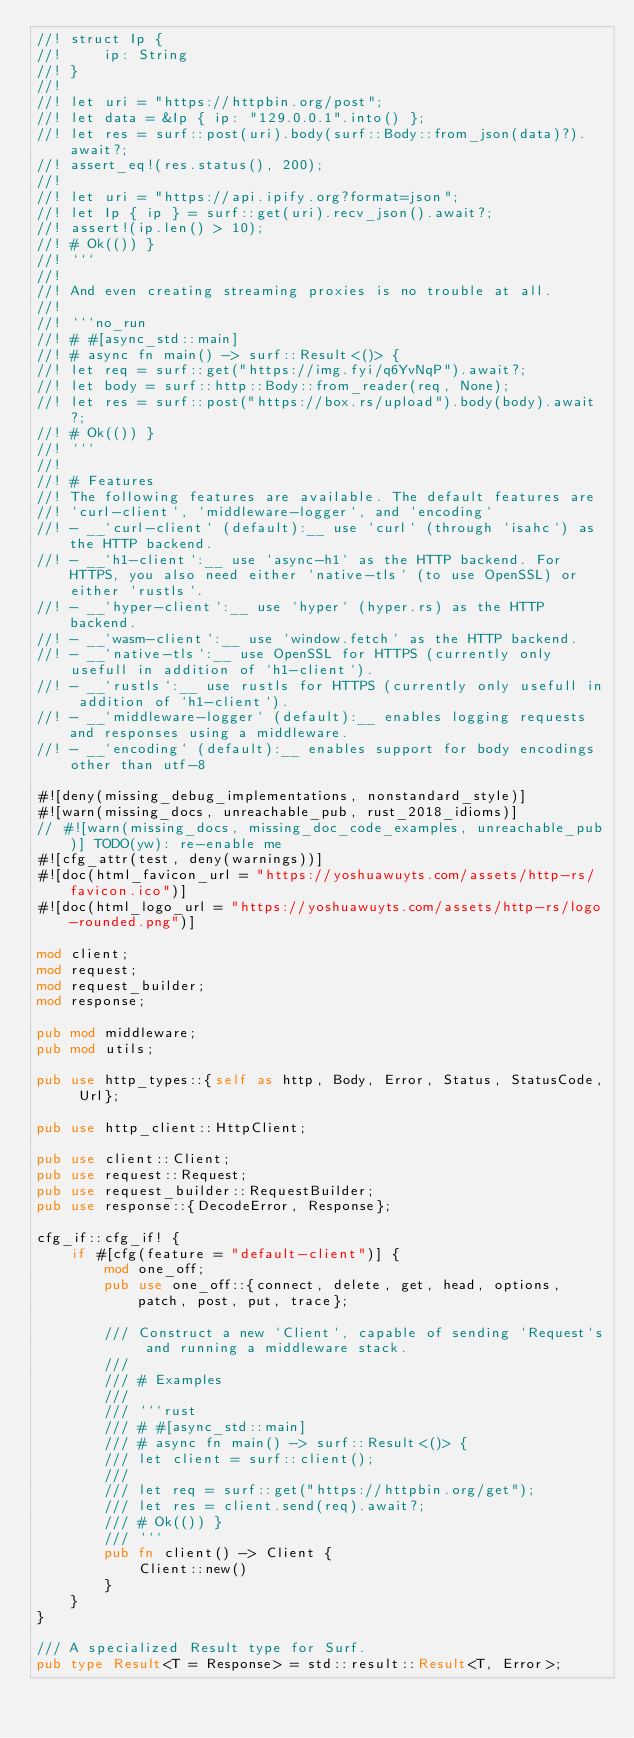Convert code to text. <code><loc_0><loc_0><loc_500><loc_500><_Rust_>//! struct Ip {
//!     ip: String
//! }
//!
//! let uri = "https://httpbin.org/post";
//! let data = &Ip { ip: "129.0.0.1".into() };
//! let res = surf::post(uri).body(surf::Body::from_json(data)?).await?;
//! assert_eq!(res.status(), 200);
//!
//! let uri = "https://api.ipify.org?format=json";
//! let Ip { ip } = surf::get(uri).recv_json().await?;
//! assert!(ip.len() > 10);
//! # Ok(()) }
//! ```
//!
//! And even creating streaming proxies is no trouble at all.
//!
//! ```no_run
//! # #[async_std::main]
//! # async fn main() -> surf::Result<()> {
//! let req = surf::get("https://img.fyi/q6YvNqP").await?;
//! let body = surf::http::Body::from_reader(req, None);
//! let res = surf::post("https://box.rs/upload").body(body).await?;
//! # Ok(()) }
//! ```
//!
//! # Features
//! The following features are available. The default features are
//! `curl-client`, `middleware-logger`, and `encoding`
//! - __`curl-client` (default):__ use `curl` (through `isahc`) as the HTTP backend.
//! - __`h1-client`:__ use `async-h1` as the HTTP backend. For HTTPS, you also need either `native-tls` (to use OpenSSL) or either `rustls`.
//! - __`hyper-client`:__ use `hyper` (hyper.rs) as the HTTP backend.
//! - __`wasm-client`:__ use `window.fetch` as the HTTP backend.
//! - __`native-tls`:__ use OpenSSL for HTTPS (currently only usefull in addition of `h1-client`).
//! - __`rustls`:__ use rustls for HTTPS (currently only usefull in addition of `h1-client`).
//! - __`middleware-logger` (default):__ enables logging requests and responses using a middleware.
//! - __`encoding` (default):__ enables support for body encodings other than utf-8

#![deny(missing_debug_implementations, nonstandard_style)]
#![warn(missing_docs, unreachable_pub, rust_2018_idioms)]
// #![warn(missing_docs, missing_doc_code_examples, unreachable_pub)] TODO(yw): re-enable me
#![cfg_attr(test, deny(warnings))]
#![doc(html_favicon_url = "https://yoshuawuyts.com/assets/http-rs/favicon.ico")]
#![doc(html_logo_url = "https://yoshuawuyts.com/assets/http-rs/logo-rounded.png")]

mod client;
mod request;
mod request_builder;
mod response;

pub mod middleware;
pub mod utils;

pub use http_types::{self as http, Body, Error, Status, StatusCode, Url};

pub use http_client::HttpClient;

pub use client::Client;
pub use request::Request;
pub use request_builder::RequestBuilder;
pub use response::{DecodeError, Response};

cfg_if::cfg_if! {
    if #[cfg(feature = "default-client")] {
        mod one_off;
        pub use one_off::{connect, delete, get, head, options, patch, post, put, trace};

        /// Construct a new `Client`, capable of sending `Request`s and running a middleware stack.
        ///
        /// # Examples
        ///
        /// ```rust
        /// # #[async_std::main]
        /// # async fn main() -> surf::Result<()> {
        /// let client = surf::client();
        ///
        /// let req = surf::get("https://httpbin.org/get");
        /// let res = client.send(req).await?;
        /// # Ok(()) }
        /// ```
        pub fn client() -> Client {
            Client::new()
        }
    }
}

/// A specialized Result type for Surf.
pub type Result<T = Response> = std::result::Result<T, Error>;
</code> 